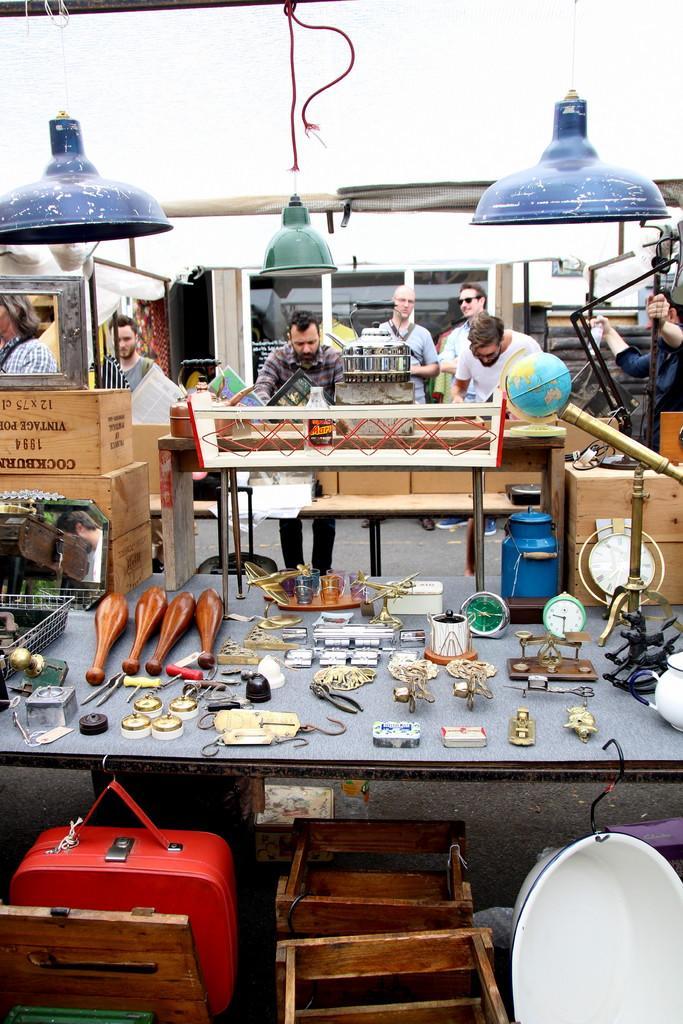In one or two sentences, can you explain what this image depicts? This image consists of tables. In the front there is a table on which there are many things and in the front a red bad is hanged to that table. To the right, there is a small globe. In the front, there are many persons sitting and standing. At the top, there are lights hanged. 